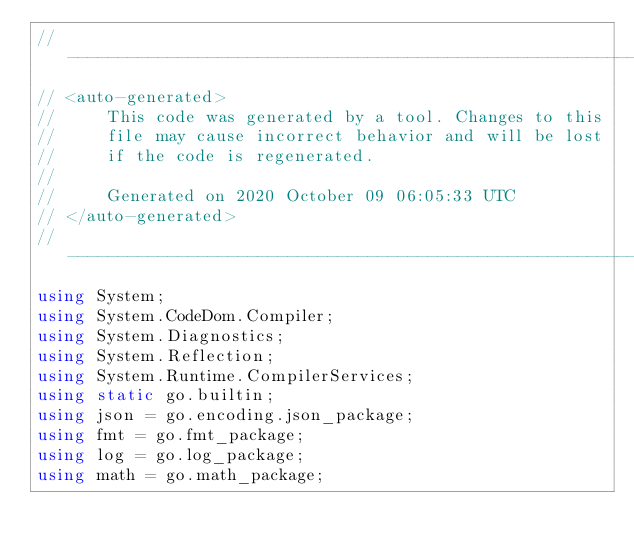<code> <loc_0><loc_0><loc_500><loc_500><_C#_>//---------------------------------------------------------
// <auto-generated>
//     This code was generated by a tool. Changes to this
//     file may cause incorrect behavior and will be lost
//     if the code is regenerated.
//
//     Generated on 2020 October 09 06:05:33 UTC
// </auto-generated>
//---------------------------------------------------------
using System;
using System.CodeDom.Compiler;
using System.Diagnostics;
using System.Reflection;
using System.Runtime.CompilerServices;
using static go.builtin;
using json = go.encoding.json_package;
using fmt = go.fmt_package;
using log = go.log_package;
using math = go.math_package;</code> 